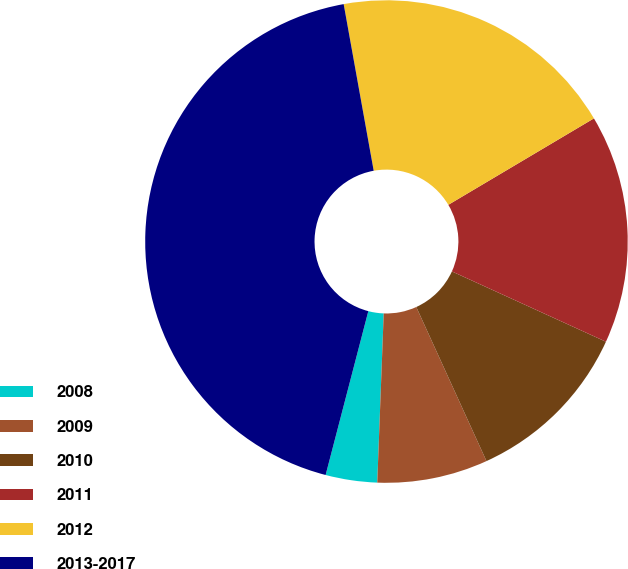Convert chart to OTSL. <chart><loc_0><loc_0><loc_500><loc_500><pie_chart><fcel>2008<fcel>2009<fcel>2010<fcel>2011<fcel>2012<fcel>2013-2017<nl><fcel>3.45%<fcel>7.41%<fcel>11.38%<fcel>15.34%<fcel>19.31%<fcel>43.1%<nl></chart> 